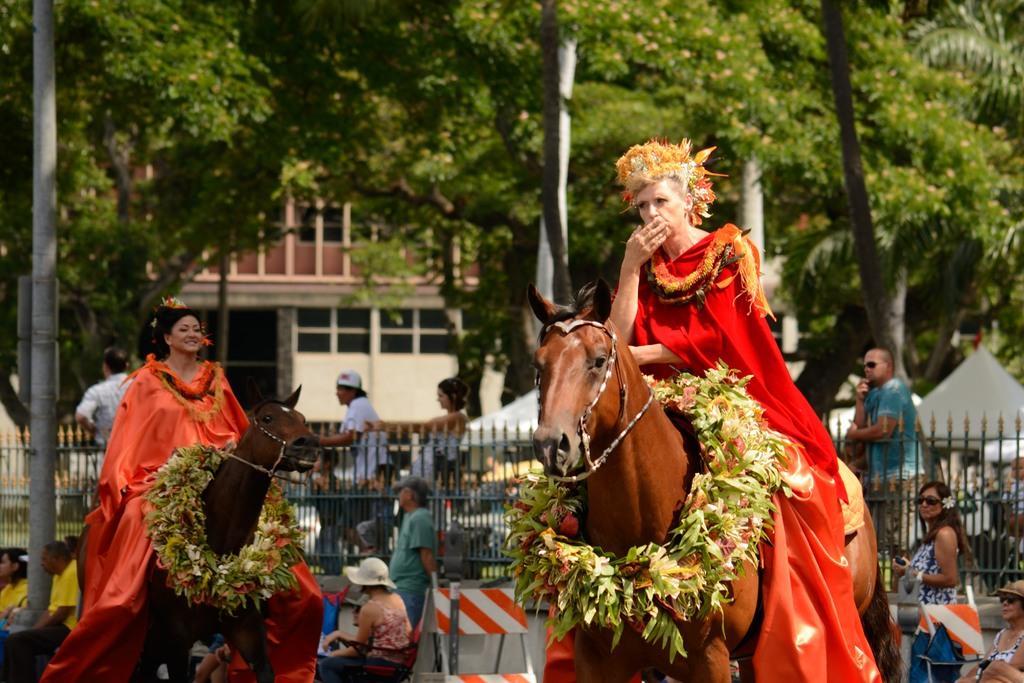Could you give a brief overview of what you see in this image? In the foreground of this image, there are two women on the horse. In the background, there are few people sitting on the chairs and few are standing. We can also see a railing, few poles, trees, tents and a building. 